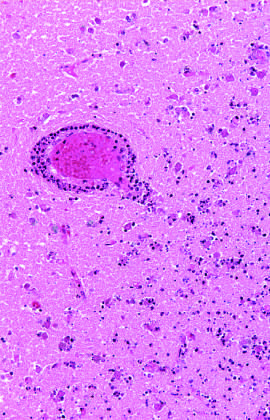does a ball of hair and a mixture of tissues begin at the edges of the lesion, where the vascular supply is intact?
Answer the question using a single word or phrase. No 